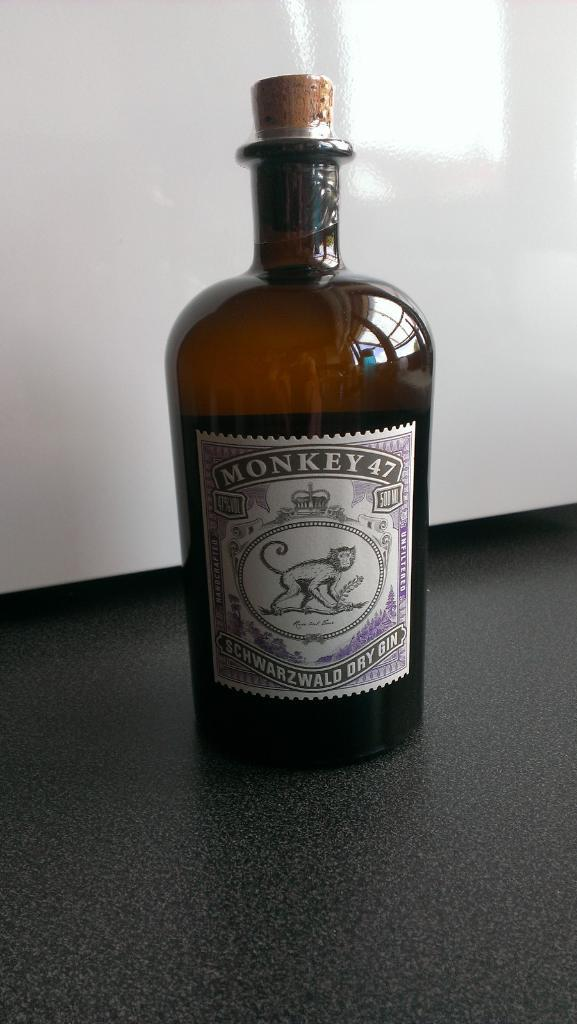<image>
Relay a brief, clear account of the picture shown. A stoppered bottle with Monkey 47 on the label. 